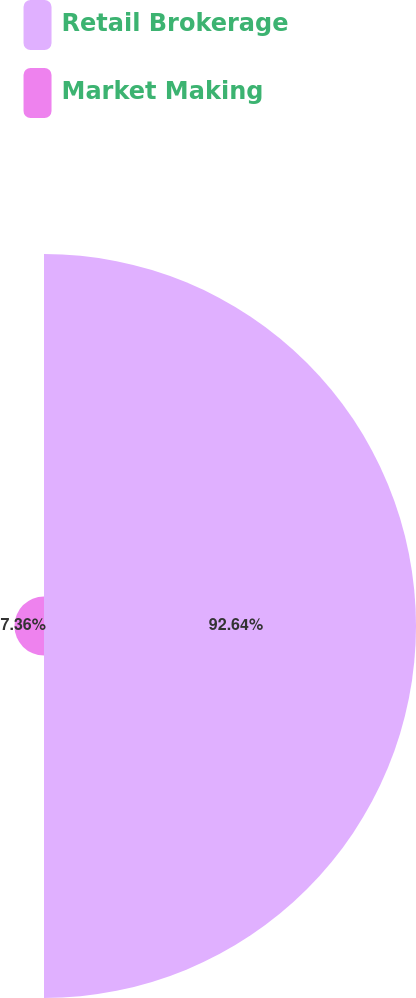Convert chart to OTSL. <chart><loc_0><loc_0><loc_500><loc_500><pie_chart><fcel>Retail Brokerage<fcel>Market Making<nl><fcel>92.64%<fcel>7.36%<nl></chart> 